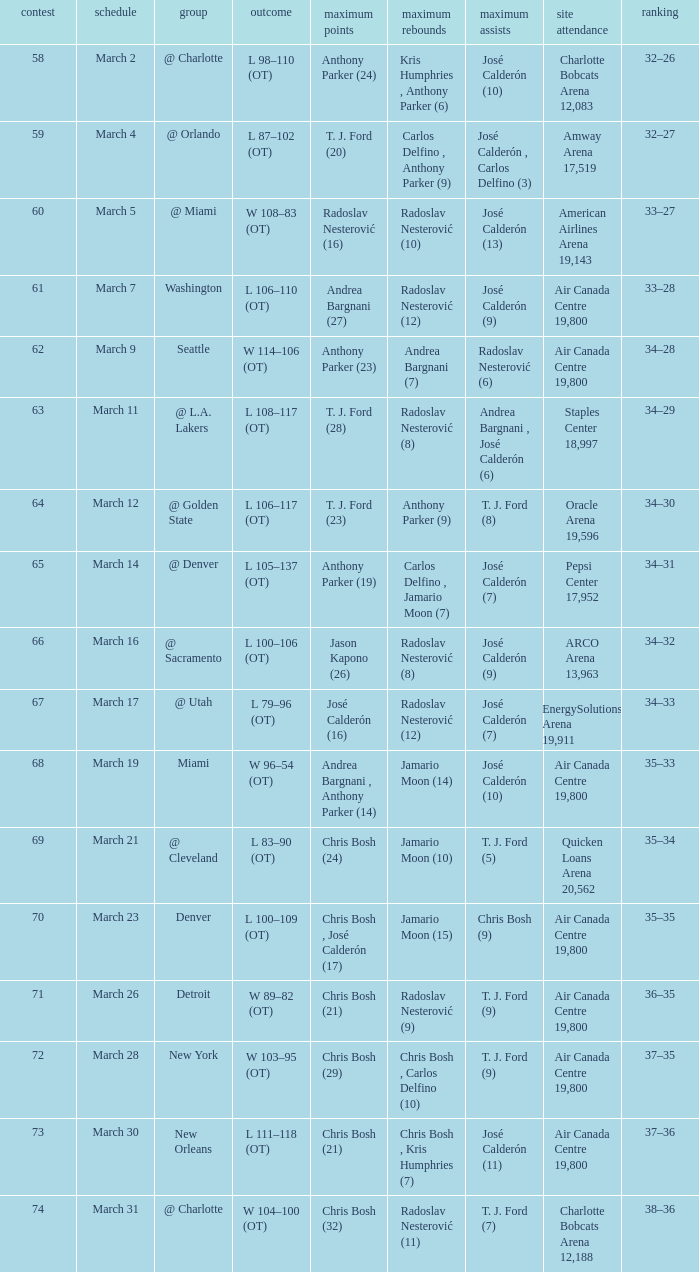How many attended the game on march 16 after over 64 games? ARCO Arena 13,963. 